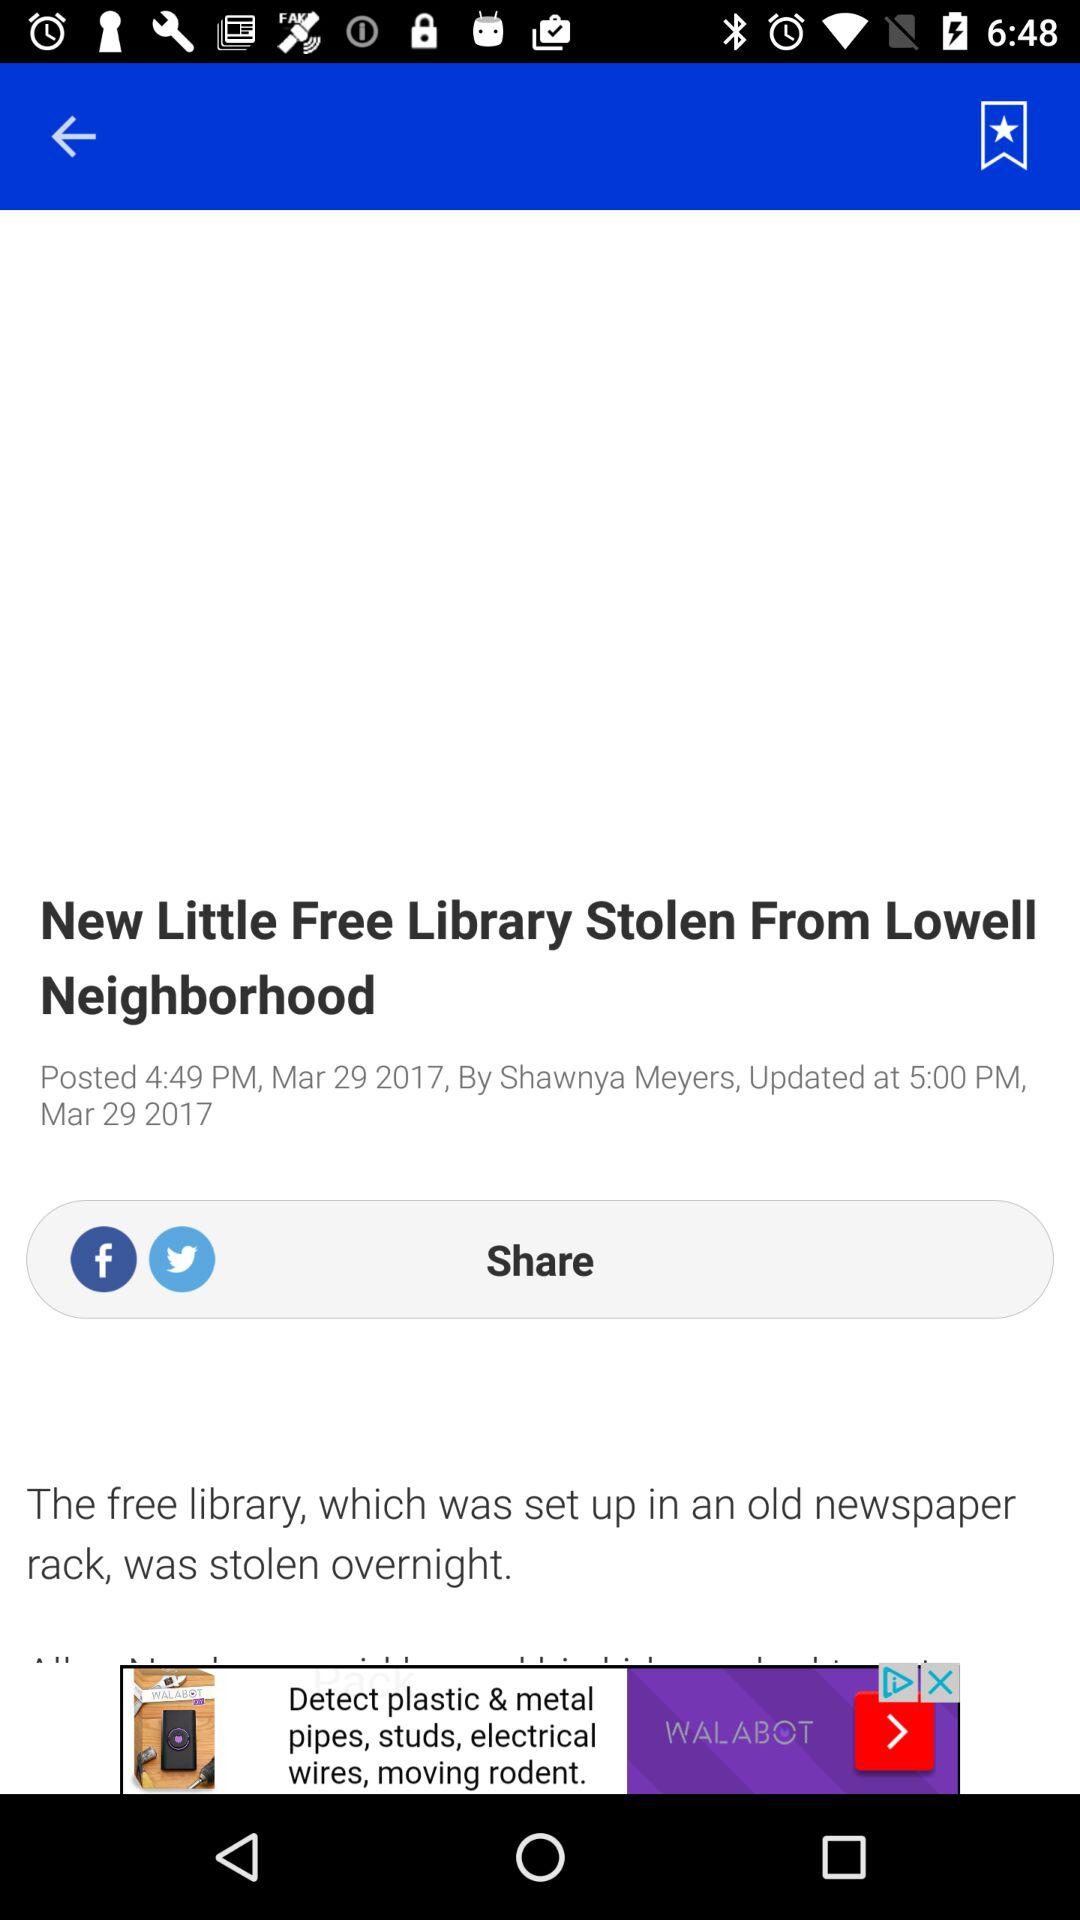Who is the author of the article? The author of the article is Shawnya Meyers. 